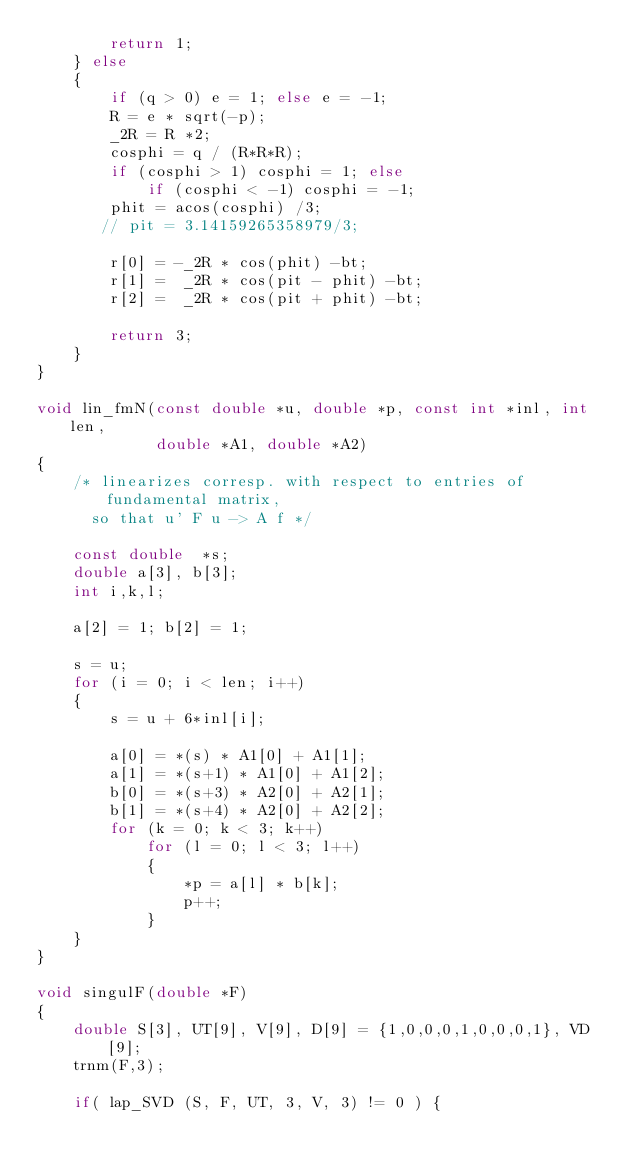<code> <loc_0><loc_0><loc_500><loc_500><_C_>        return 1;
    } else
    {
        if (q > 0) e = 1; else e = -1;
        R = e * sqrt(-p);
        _2R = R *2;
        cosphi = q / (R*R*R);
        if (cosphi > 1) cosphi = 1; else
            if (cosphi < -1) cosphi = -1;
        phit = acos(cosphi) /3;
       // pit = 3.14159265358979/3;

        r[0] = -_2R * cos(phit) -bt;
        r[1] =  _2R * cos(pit - phit) -bt;
        r[2] =  _2R * cos(pit + phit) -bt;

        return 3;
    }
}

void lin_fmN(const double *u, double *p, const int *inl, int len,
             double *A1, double *A2)
{
    /* linearizes corresp. with respect to entries of fundamental matrix,
      so that u' F u -> A f */

    const double  *s;
    double a[3], b[3];
    int i,k,l;

    a[2] = 1; b[2] = 1;

    s = u;
    for (i = 0; i < len; i++)
    {
        s = u + 6*inl[i];

        a[0] = *(s) * A1[0] + A1[1];
        a[1] = *(s+1) * A1[0] + A1[2];
        b[0] = *(s+3) * A2[0] + A2[1];
        b[1] = *(s+4) * A2[0] + A2[2];
        for (k = 0; k < 3; k++)
            for (l = 0; l < 3; l++)
            {
                *p = a[l] * b[k];
                p++;
            }
    }
}

void singulF(double *F)
{
    double S[3], UT[9], V[9], D[9] = {1,0,0,0,1,0,0,0,1}, VD[9];
    trnm(F,3);

    if( lap_SVD (S, F, UT, 3, V, 3) != 0 ) {</code> 